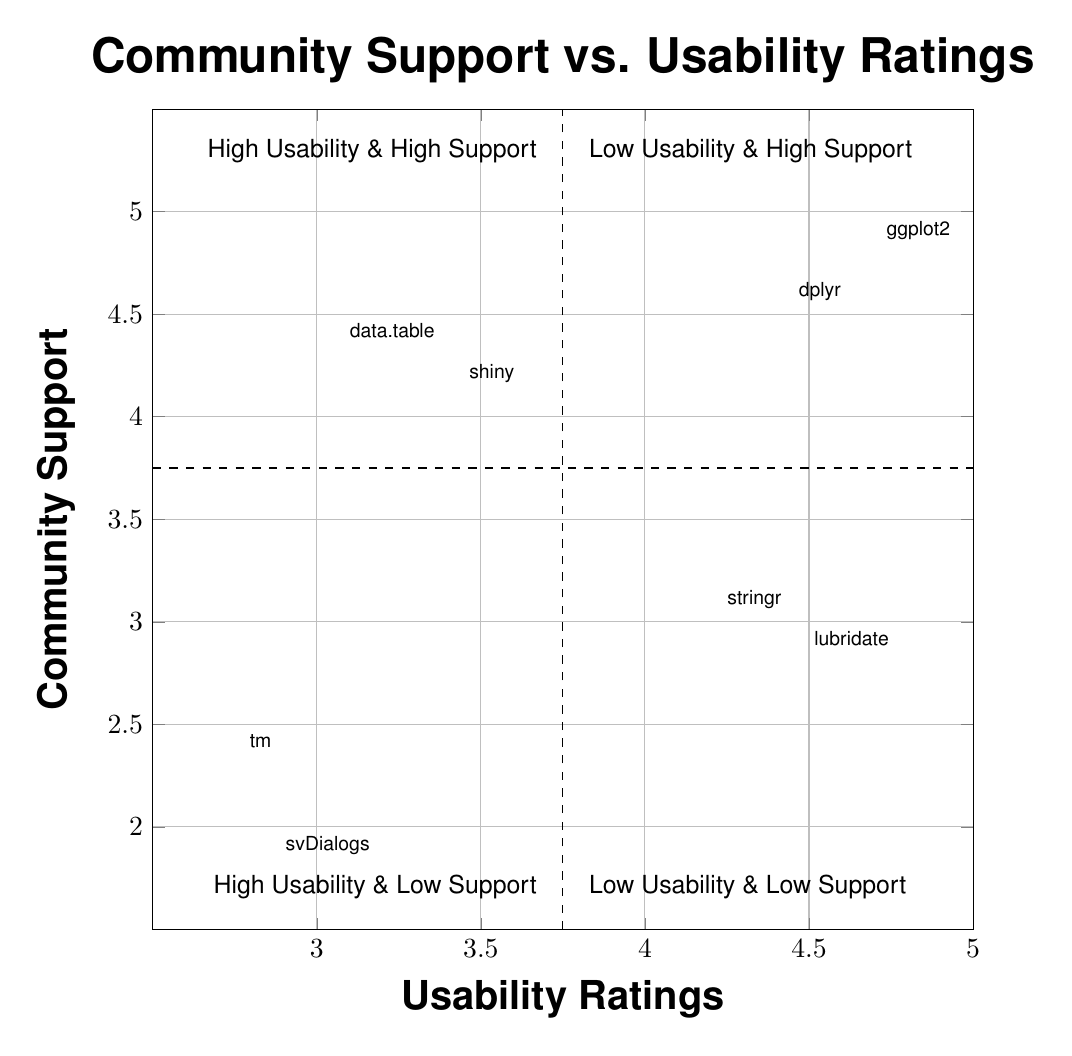What is the usability rating of ggplot2? The diagram shows the coordinate for ggplot2 at (4.8, 5.0). Thus, the usability rating, which is the x-coordinate, is 4.8.
Answer: 4.8 How many packages are in the "High Usability & Low Support" quadrant? The "High Usability & Low Support" quadrant contains two elements: lubridate and stringr. Therefore, the count is 2.
Answer: 2 Which package has the lowest usability rating? By examining the coordinates in all quadrants, tm has the lowest usability rating at 2.8, located in the "Low Usability & Low Support" quadrant.
Answer: tm What is the community support rating of dplyr? The diagram indicates that dplyr is located at the coordinates (4.5, 4.7). Therefore, the community support rating, the y-coordinate, is 4.7.
Answer: 4.7 Which quadrant contains data.table? The data.table is positioned at (3.2, 4.5), which places it in the "Low Usability & High Support" quadrant as its usability rating is below 3.75.
Answer: Low Usability & High Support How does the community support rating of stringr compare to that of lubridate? The community support rating of stringr is 3.2, while lubridate has a rating of 3.0. Since 3.2 is greater than 3.0, stringr has better community support than lubridate.
Answer: Stringr has better support What overall trend can be observed in the "Low Usability & High Support" quadrant? In the "Low Usability & High Support" quadrant, both packages (data.table and shiny) exhibit low usability ratings (below 4), paired with relatively higher community support ratings (above 4). This trend indicates that usability does not always correlate positively with support in this case.
Answer: Low usability, high support trend Which package in the "High Usability & High Support" quadrant has the lower usability rating? Between ggplot2 (4.8) and dplyr (4.5) in the "High Usability & High Support" quadrant, dplyr has the lower usability rating at 4.5.
Answer: dplyr What does the division line at x=3.75 represent? The division line at x=3.75 distinguishes between low usability (left side) and high usability (right side), indicating how packages are categorized based on their usability ratings.
Answer: Usability threshold 